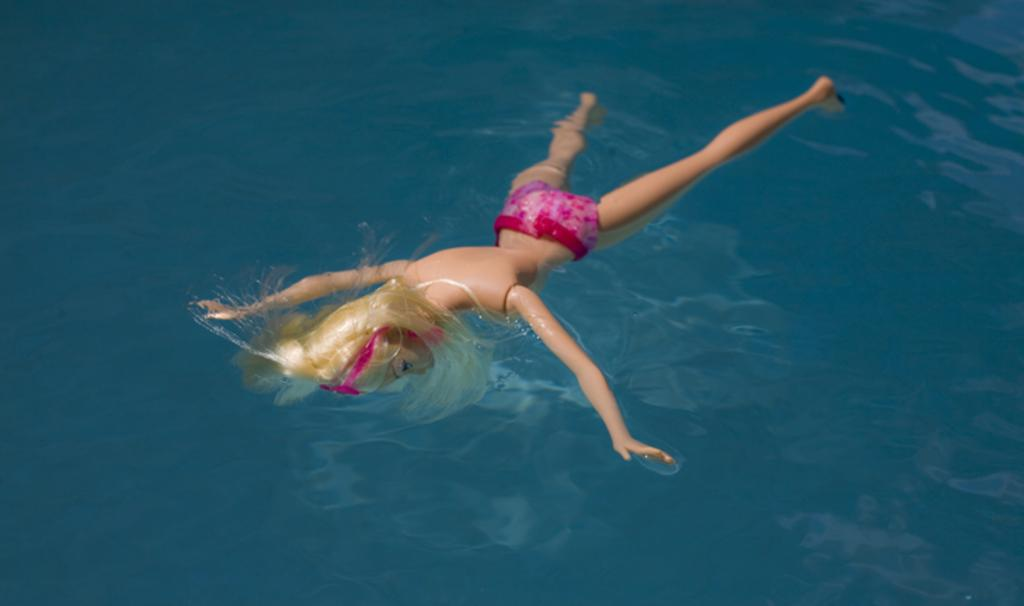What is the main subject of the image? There is a doll in the image. What is the doll doing in the image? The doll is floating on the water. What color is the doll? The doll is in cream color. What color is the water in the image? The water is in blue color. What type of rice is being harvested in the image? There is no rice or harvesting activity present in the image; it features a doll floating on blue water. 